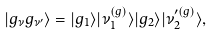Convert formula to latex. <formula><loc_0><loc_0><loc_500><loc_500>| g _ { \nu } g _ { \nu ^ { \prime } } \rangle = | g _ { 1 } \rangle | \nu _ { 1 } ^ { ( g ) } \rangle | g _ { 2 } \rangle | \nu _ { 2 } ^ { \prime ( g ) } \rangle ,</formula> 